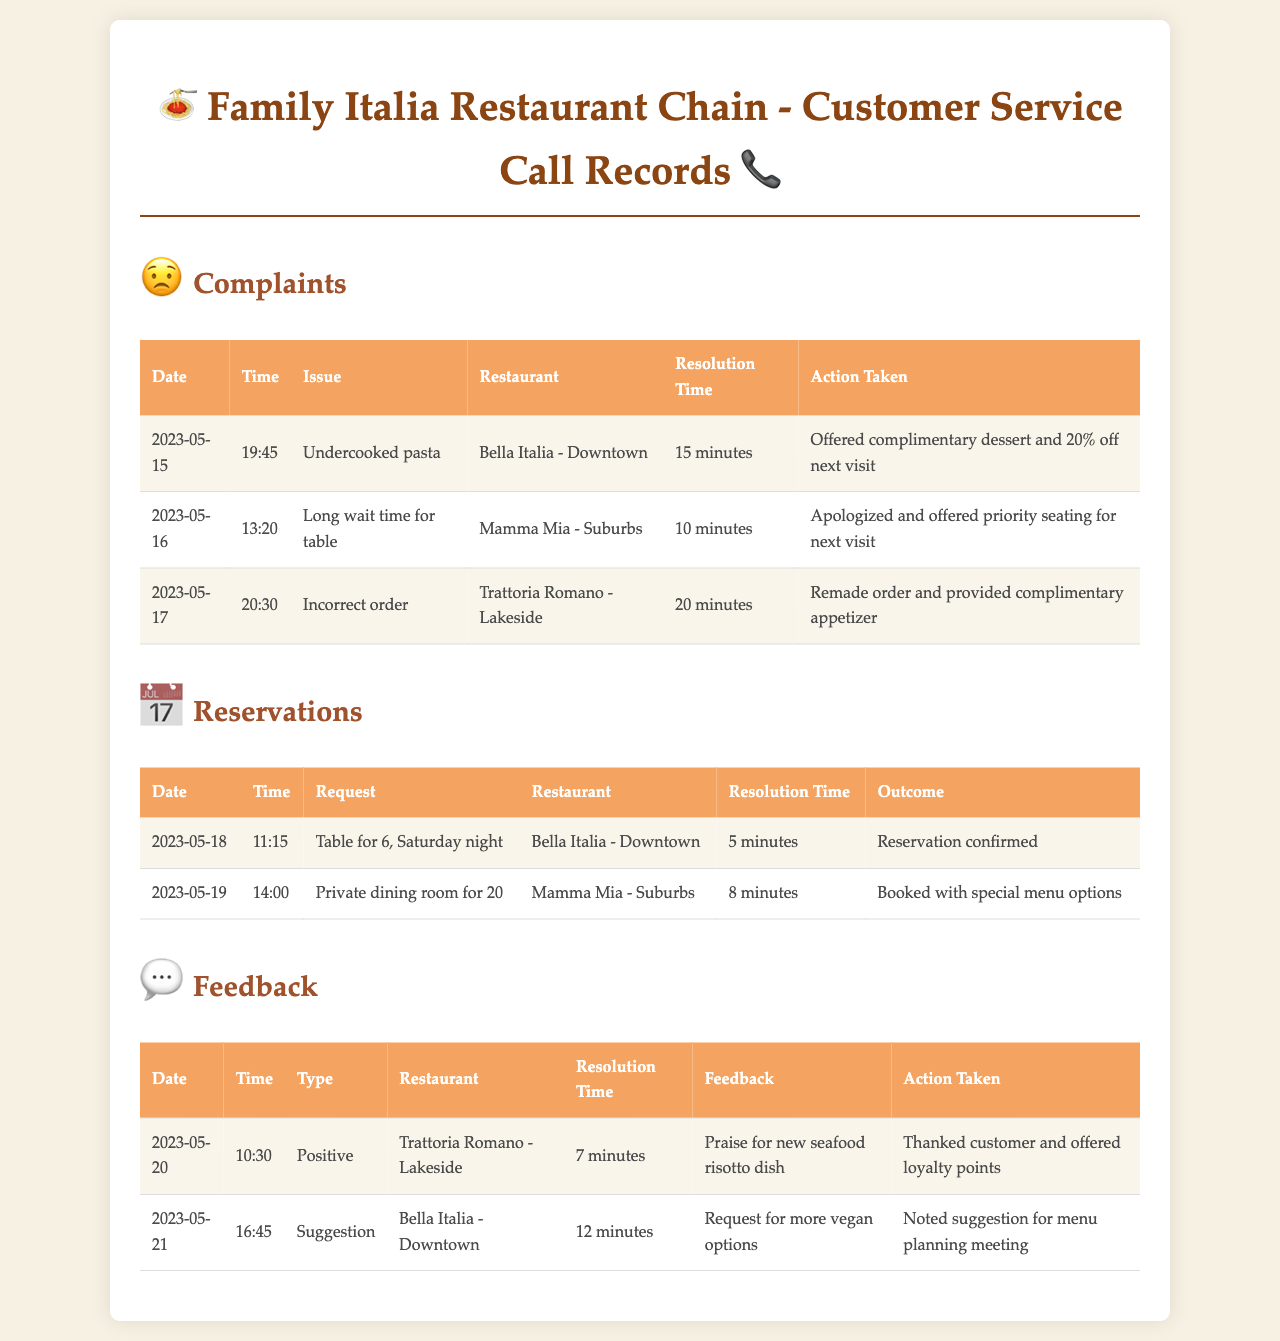what is the date of the complaint regarding undercooked pasta? The date of the complaint can be found in the first row of the complaints table which shows May 15, 2023.
Answer: 2023-05-15 how long did it take to resolve the incorrect order issue? The resolution time for the incorrect order issue is mentioned in the complaints table as 20 minutes.
Answer: 20 minutes what was offered for the long wait time for a table? The action taken for the long wait time is stated as apologizing and offering priority seating for the next visit.
Answer: Priority seating how many feedback entries are positive? There are two entries under feedback, with one being positive, specifically on May 20, 2023.
Answer: 1 which restaurant had a complaint about incorrect orders? The restaurant with a complaint regarding incorrect orders is listed as Trattoria Romano - Lakeside in the complaints section.
Answer: Trattoria Romano - Lakeside what specific suggestion was noted for Bella Italia - Downtown? The suggestion noted for Bella Italia - Downtown was for more vegan options, as found in the feedback table.
Answer: More vegan options how many total reservations were listed in the records? There are two rows in the reservations table, indicating two reservation entries were made.
Answer: 2 what was the resolution time for the private dining room request? The resolution time for the request of a private dining room for 20 is 8 minutes, as indicated in the reservations table.
Answer: 8 minutes what type of feedback was received on May 21, 2023? The feedback received on this date is categorized as a suggestion regarding menu options, as noted in the feedback table.
Answer: Suggestion 